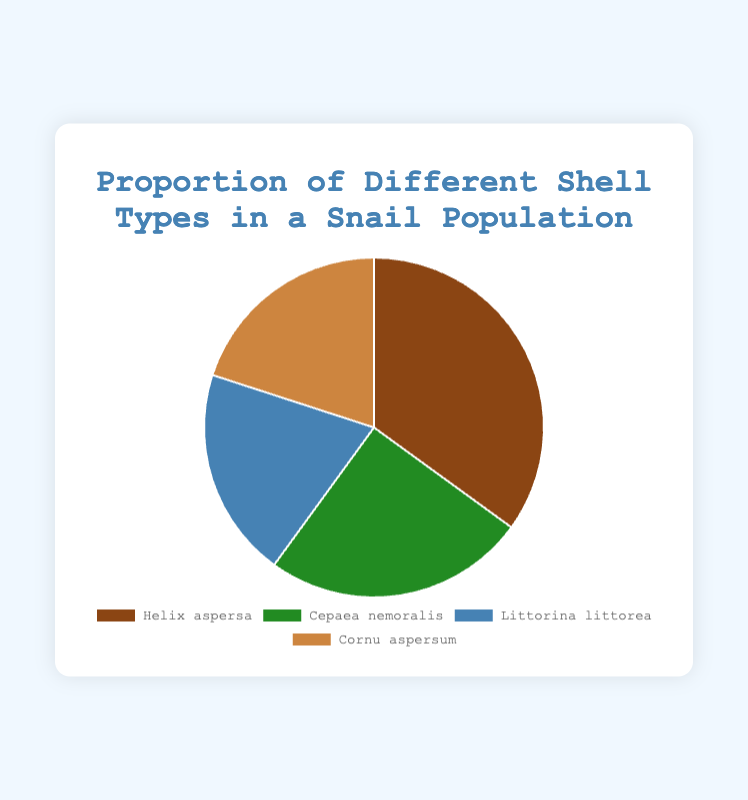Which shell type has the highest proportion in the snail population? The figure shows that Helix aspersa has the largest slice of the pie chart. Looking at the proportions provided, Helix aspersa has a value of 35%.
Answer: Helix aspersa Which shell types have the same proportion in the snail population? The pie chart indicates that Littorina littorea and Cornu aspersum have equally sized slices. Reviewing the provided data confirms both have a proportion of 20%.
Answer: Littorina littorea and Cornu aspersum By how much is the proportion of Helix aspersa greater than Cepaea nemoralis? Helix aspersa has a proportion of 35%, while Cepaea nemoralis has 25%. The difference between them is 35% - 25% = 10%.
Answer: 10% What is the combined proportion of Littorina littorea and Cornu aspersum? Both Littorina littorea and Cornu aspersum have proportions of 20%. Adding them together gives 20% + 20% = 40%.
Answer: 40% What is the average proportion of the four shell types in the snail population? Sum up the proportions which are 35%, 25%, 20%, and 20%. The sum is 100%. Divide by the number of shell types, which is 4. Thus, 100% / 4 = 25%.
Answer: 25% Which shell type has the smallest proportion and what is it? The pie chart shows the smallest slices belonging to Littorina littorea and Cornu aspersum. Both have a proportion of 20%.
Answer: Littorina littorea and Cornu aspersum, 20% What percentage of the snail population is made up by Helix aspersa and Cepaea nemoralis combined? Helix aspersa has a proportion of 35%, and Cepaea nemoralis has 25%. Adding them together gives 35% + 25% = 60%.
Answer: 60% 